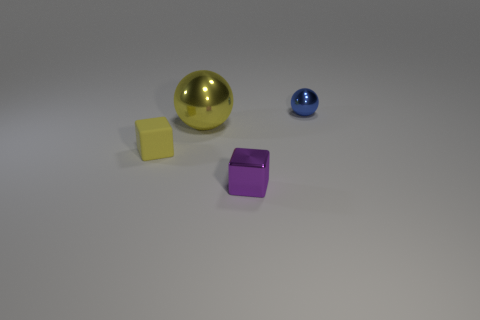Add 1 big green blocks. How many objects exist? 5 Subtract 0 cyan cubes. How many objects are left? 4 Subtract all rubber cubes. Subtract all spheres. How many objects are left? 1 Add 1 small blue spheres. How many small blue spheres are left? 2 Add 4 yellow metal blocks. How many yellow metal blocks exist? 4 